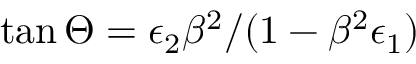Convert formula to latex. <formula><loc_0><loc_0><loc_500><loc_500>\tan \Theta = \epsilon _ { 2 } \beta ^ { 2 } / ( 1 - \beta ^ { 2 } \epsilon _ { 1 } )</formula> 